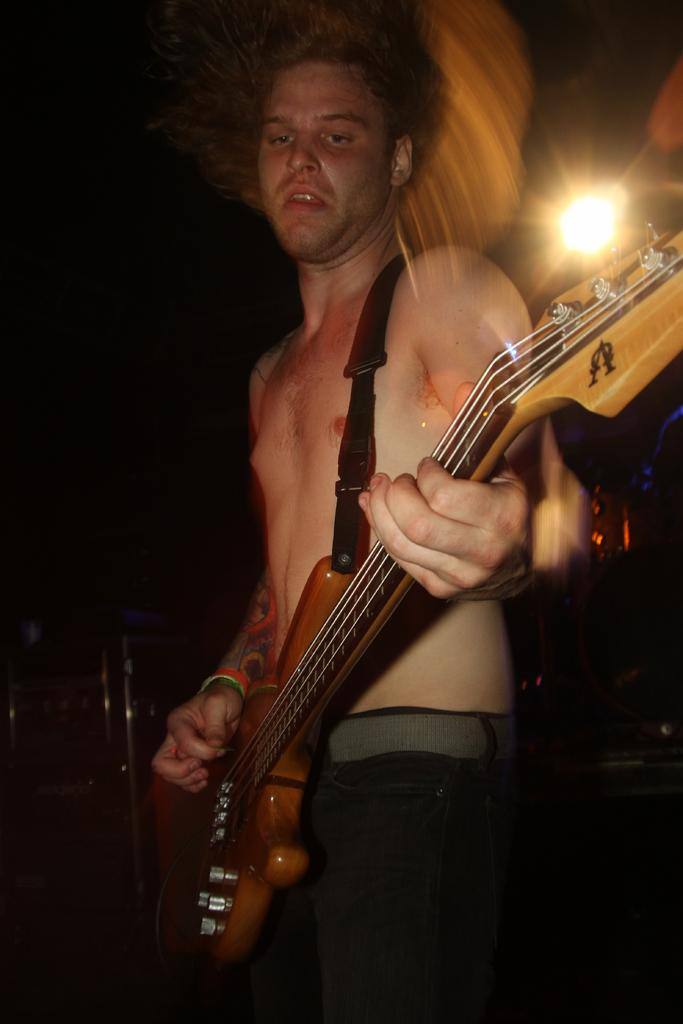What is the main subject of the image? The main subject of the image is a guy. What is the guy holding in the image? The guy is holding a guitar in the image. What is the guy doing with the guitar? The guy is playing the guitar in the image. Can you describe the lighting in the image? There is a light behind the guy in the image. What type of baseball equipment can be seen in the image? There is no baseball equipment present in the image. What role does the guy play in the war depicted in the image? There is no war depicted in the image, and the guy is simply playing a guitar. 